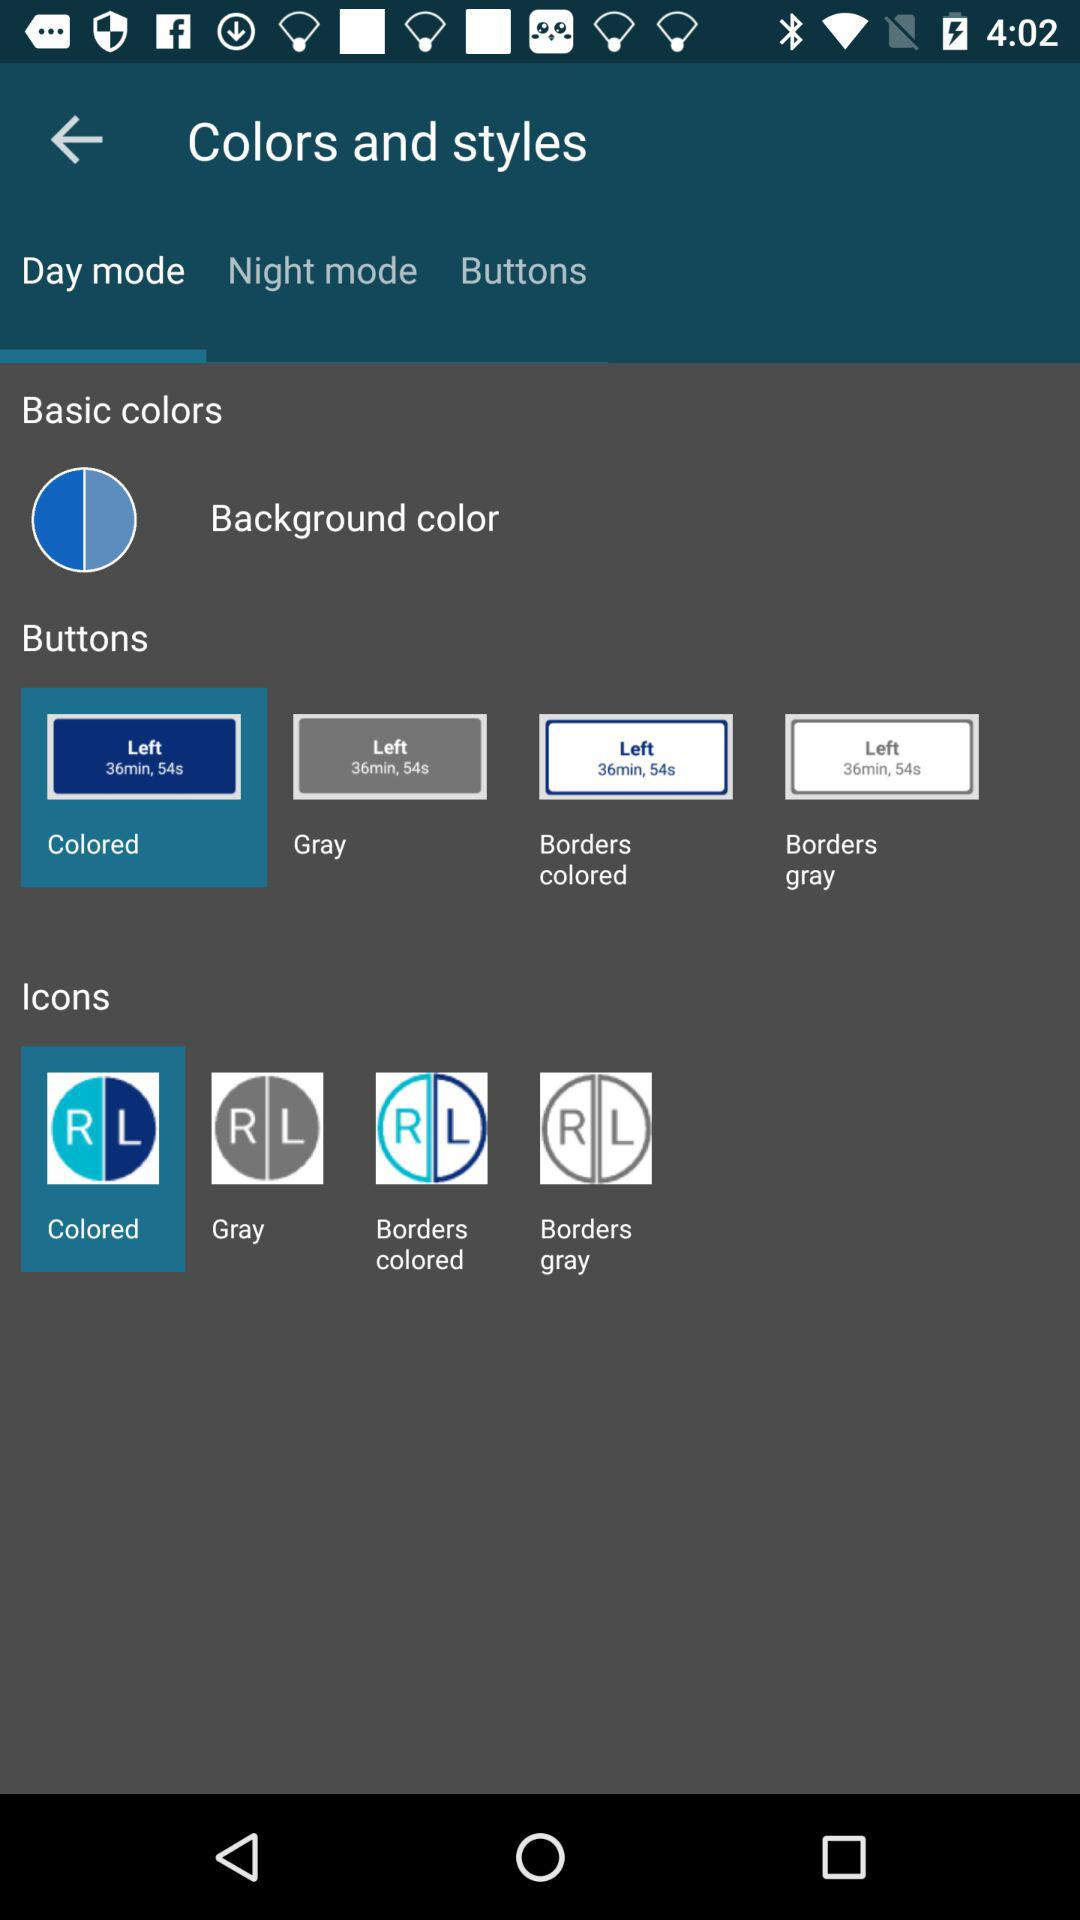Which tab am I on? You are on the "Day mode" tab. 